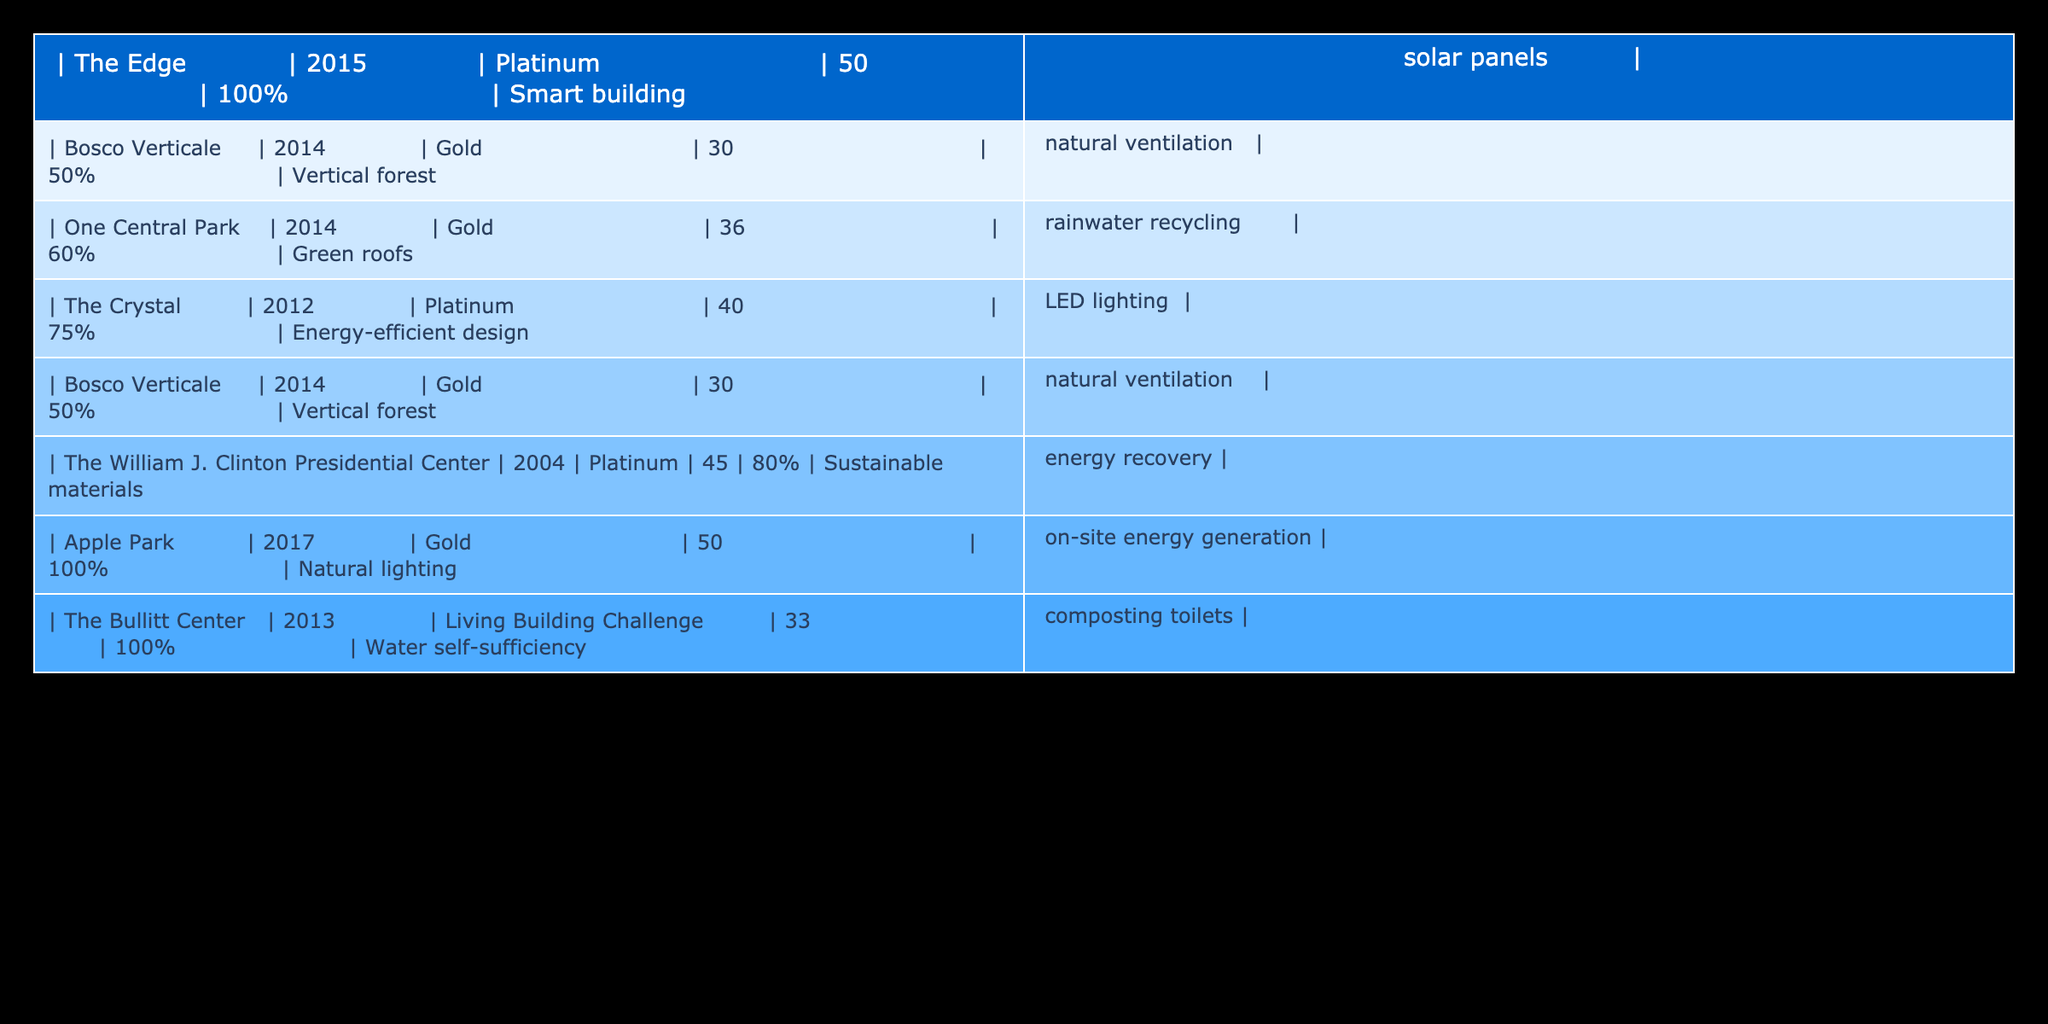What is the energy efficiency rating of The Edge? The table indicates that The Edge has a rating of Platinum. This is directly visible in the second column of the corresponding row.
Answer: Platinum Which building has the highest water efficiency percentage? By looking at the columns for water efficiency percentage, The Bullitt Center has the highest value of 100%. It can be found in the last column of its row.
Answer: 100% How many buildings achieved a Platinum energy efficiency rating? The table shows that The Edge, The Crystal, and The William J. Clinton Presidential Center each have a Platinum rating. Counting these entries yields three buildings.
Answer: 3 What is the average water efficiency percentage of buildings with a Gold rating? The buildings that achieved a Gold rating are Bosco Verticale, One Central Park, and Apple Park. Their respective water efficiency percentages are 50%, 60%, and 100%. Summing these gives 210%, and dividing by 3 (the number of buildings) gives an average of 70%.
Answer: 70% Is there any building in the table that has a rating lower than Gold? The Bullitt Center holds a Living Building Challenge rating, which is considered lower than Gold by conventional standards. Thus, the answer is yes.
Answer: Yes Which building features a vertical forest design? Bosco Verticale, mentioned in the second column, is the building known for its vertical forest design based on its description in the last column.
Answer: Bosco Verticale What is the difference in water efficiency percentage between The Crystal and The Bullitt Center? The Crystal has a water efficiency percentage of 75%, and The Bullitt Center has 100%. The difference is calculated by subtracting 75 from 100, which results in 25.
Answer: 25 Are there more buildings with a rating of Gold than those with Platinum? The table contains three buildings with a Gold rating (Bosco Verticale, One Central Park, Apple Park) and three with a Platinum rating (The Edge, The Crystal, The William J. Clinton Presidential Center). Since the numbers are equal, the answer is no.
Answer: No Which building has the lowest energy efficiency rating and what is it? In the data, The Bullitt Center has the Living Building Challenge rating, which is lower than Gold and is the only one in that category among other ratings. Thus, it is identified as the building with the lowest rating and has the rating of Living Building Challenge.
Answer: Living Building Challenge 